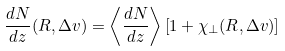Convert formula to latex. <formula><loc_0><loc_0><loc_500><loc_500>\frac { d N } { d z } ( R , \Delta v ) = \left \langle \frac { d N } { d z } \right \rangle \left [ 1 + \chi _ { \perp } ( R , \Delta v ) \right ]</formula> 